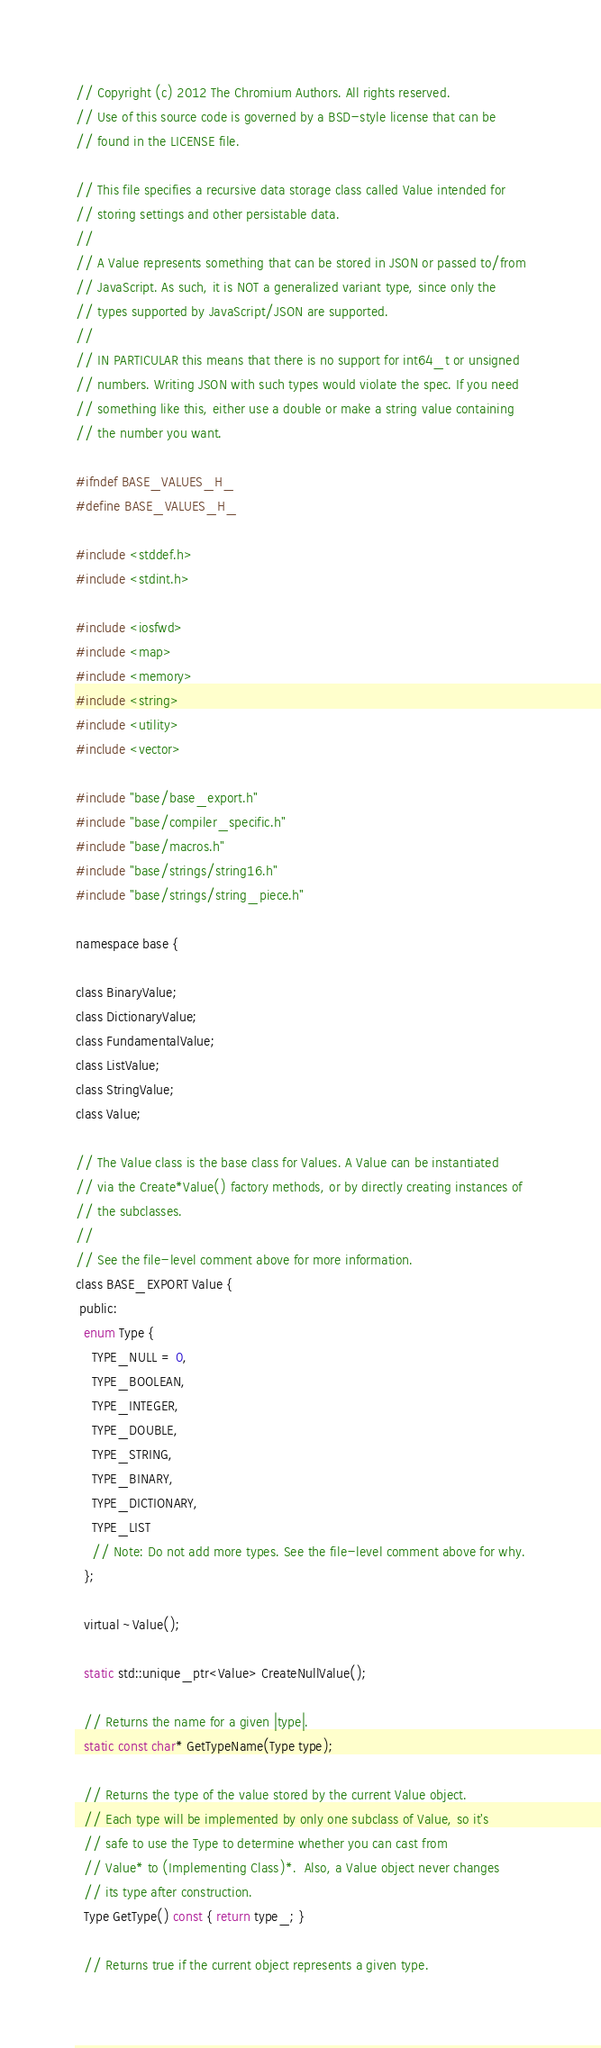Convert code to text. <code><loc_0><loc_0><loc_500><loc_500><_C_>// Copyright (c) 2012 The Chromium Authors. All rights reserved.
// Use of this source code is governed by a BSD-style license that can be
// found in the LICENSE file.

// This file specifies a recursive data storage class called Value intended for
// storing settings and other persistable data.
//
// A Value represents something that can be stored in JSON or passed to/from
// JavaScript. As such, it is NOT a generalized variant type, since only the
// types supported by JavaScript/JSON are supported.
//
// IN PARTICULAR this means that there is no support for int64_t or unsigned
// numbers. Writing JSON with such types would violate the spec. If you need
// something like this, either use a double or make a string value containing
// the number you want.

#ifndef BASE_VALUES_H_
#define BASE_VALUES_H_

#include <stddef.h>
#include <stdint.h>

#include <iosfwd>
#include <map>
#include <memory>
#include <string>
#include <utility>
#include <vector>

#include "base/base_export.h"
#include "base/compiler_specific.h"
#include "base/macros.h"
#include "base/strings/string16.h"
#include "base/strings/string_piece.h"

namespace base {

class BinaryValue;
class DictionaryValue;
class FundamentalValue;
class ListValue;
class StringValue;
class Value;

// The Value class is the base class for Values. A Value can be instantiated
// via the Create*Value() factory methods, or by directly creating instances of
// the subclasses.
//
// See the file-level comment above for more information.
class BASE_EXPORT Value {
 public:
  enum Type {
    TYPE_NULL = 0,
    TYPE_BOOLEAN,
    TYPE_INTEGER,
    TYPE_DOUBLE,
    TYPE_STRING,
    TYPE_BINARY,
    TYPE_DICTIONARY,
    TYPE_LIST
    // Note: Do not add more types. See the file-level comment above for why.
  };

  virtual ~Value();

  static std::unique_ptr<Value> CreateNullValue();

  // Returns the name for a given |type|.
  static const char* GetTypeName(Type type);

  // Returns the type of the value stored by the current Value object.
  // Each type will be implemented by only one subclass of Value, so it's
  // safe to use the Type to determine whether you can cast from
  // Value* to (Implementing Class)*.  Also, a Value object never changes
  // its type after construction.
  Type GetType() const { return type_; }

  // Returns true if the current object represents a given type.</code> 